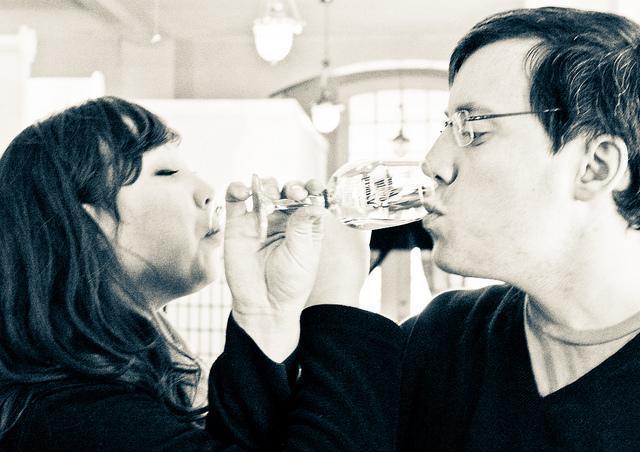What kind of beverage are the couple most likely drinking together?
Indicate the correct response and explain using: 'Answer: answer
Rationale: rationale.'
Options: Water, wine, beer, juice. Answer: water.
Rationale: The couple are interlocking arms and drinking each others fluid out of their fancy stemmed glass. 